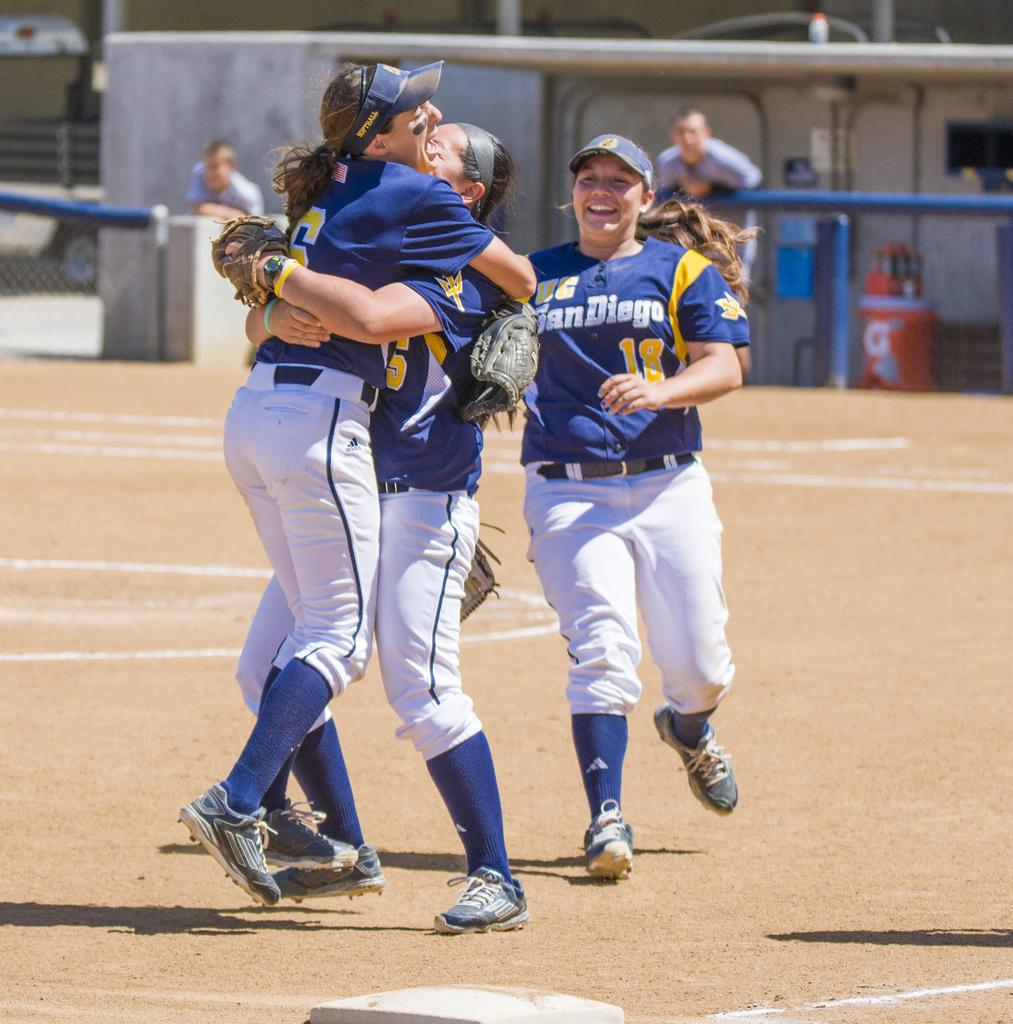Provide a one-sentence caption for the provided image. women from the UC San Diego ball league hug on the field. 